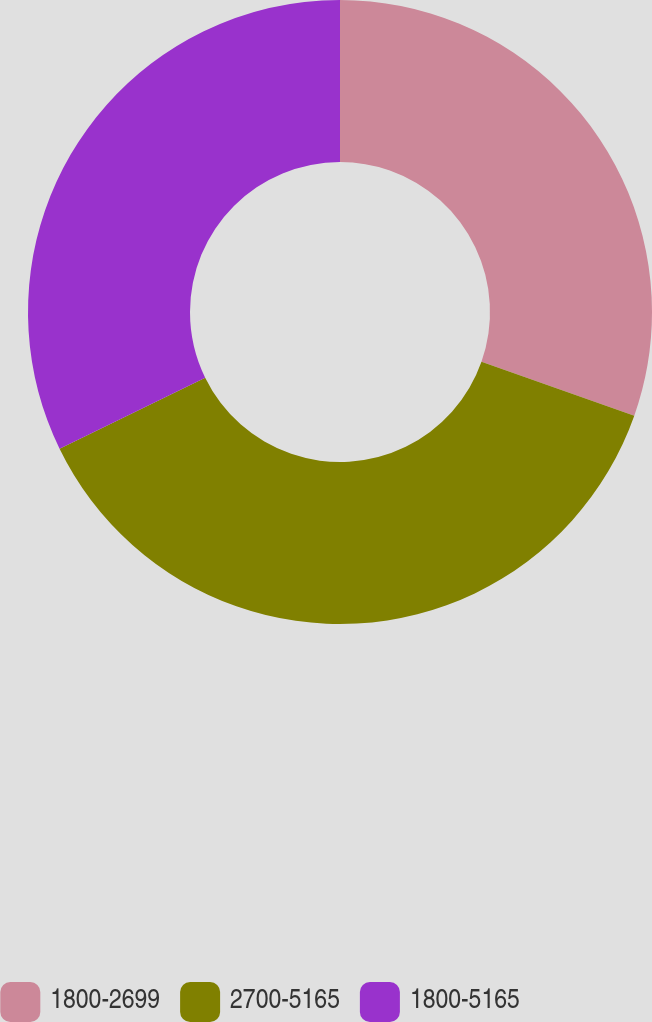<chart> <loc_0><loc_0><loc_500><loc_500><pie_chart><fcel>1800-2699<fcel>2700-5165<fcel>1800-5165<nl><fcel>30.39%<fcel>37.39%<fcel>32.22%<nl></chart> 